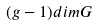Convert formula to latex. <formula><loc_0><loc_0><loc_500><loc_500>( g - 1 ) d i m G</formula> 